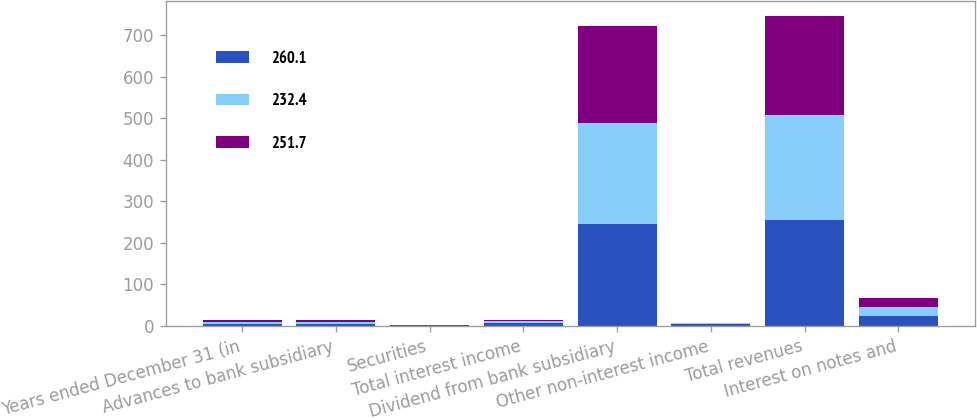Convert chart to OTSL. <chart><loc_0><loc_0><loc_500><loc_500><stacked_bar_chart><ecel><fcel>Years ended December 31 (in<fcel>Advances to bank subsidiary<fcel>Securities<fcel>Total interest income<fcel>Dividend from bank subsidiary<fcel>Other non-interest income<fcel>Total revenues<fcel>Interest on notes and<nl><fcel>260.1<fcel>4.8<fcel>4.4<fcel>1.1<fcel>5.5<fcel>245<fcel>4.2<fcel>254.7<fcel>22.5<nl><fcel>232.4<fcel>4.8<fcel>4.4<fcel>0.4<fcel>4.8<fcel>244<fcel>1.2<fcel>252.3<fcel>22.4<nl><fcel>251.7<fcel>4.8<fcel>4.1<fcel>0.3<fcel>4.4<fcel>232<fcel>2<fcel>238.4<fcel>23<nl></chart> 